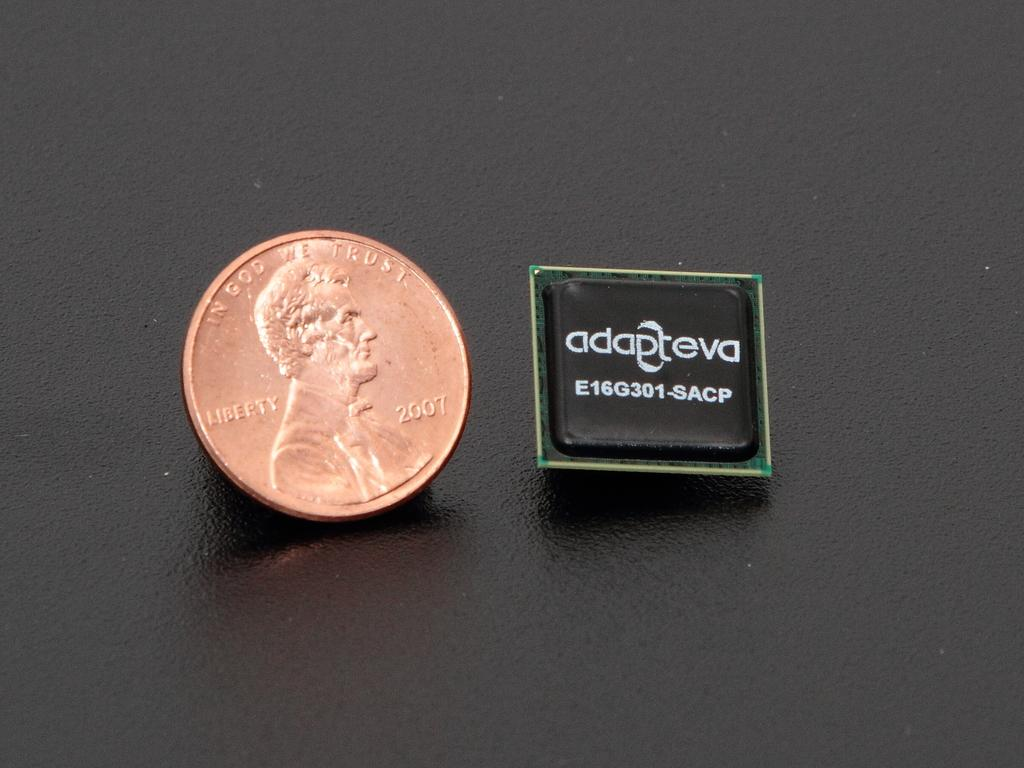Provide a one-sentence caption for the provided image. Adapteva the company picturing a 2007 USA penny. 